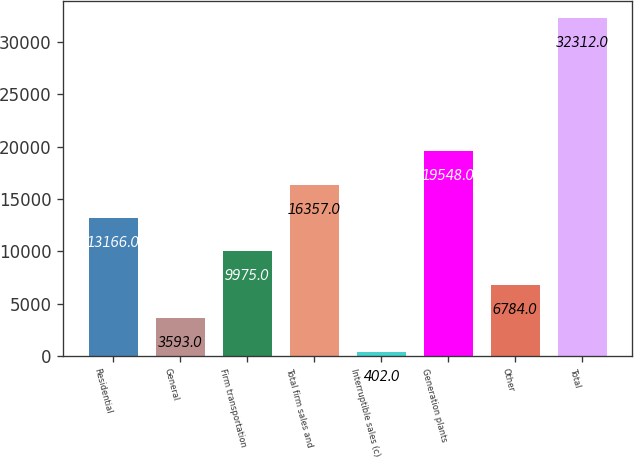Convert chart to OTSL. <chart><loc_0><loc_0><loc_500><loc_500><bar_chart><fcel>Residential<fcel>General<fcel>Firm transportation<fcel>Total firm sales and<fcel>Interruptible sales (c)<fcel>Generation plants<fcel>Other<fcel>Total<nl><fcel>13166<fcel>3593<fcel>9975<fcel>16357<fcel>402<fcel>19548<fcel>6784<fcel>32312<nl></chart> 